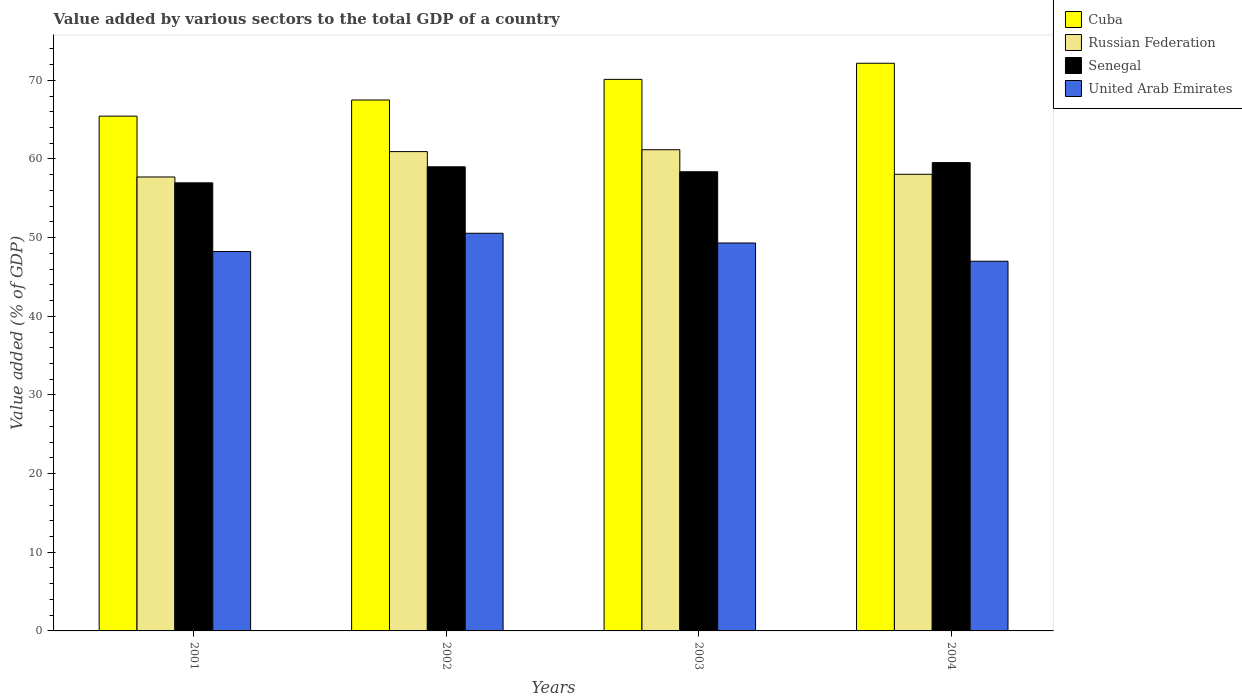How many different coloured bars are there?
Your response must be concise. 4. How many groups of bars are there?
Your answer should be very brief. 4. Are the number of bars per tick equal to the number of legend labels?
Your response must be concise. Yes. How many bars are there on the 3rd tick from the left?
Offer a very short reply. 4. What is the value added by various sectors to the total GDP in United Arab Emirates in 2004?
Your response must be concise. 47. Across all years, what is the maximum value added by various sectors to the total GDP in United Arab Emirates?
Ensure brevity in your answer.  50.56. Across all years, what is the minimum value added by various sectors to the total GDP in Russian Federation?
Ensure brevity in your answer.  57.71. In which year was the value added by various sectors to the total GDP in Cuba maximum?
Ensure brevity in your answer.  2004. What is the total value added by various sectors to the total GDP in Russian Federation in the graph?
Offer a very short reply. 237.87. What is the difference between the value added by various sectors to the total GDP in United Arab Emirates in 2001 and that in 2003?
Ensure brevity in your answer.  -1.08. What is the difference between the value added by various sectors to the total GDP in Cuba in 2001 and the value added by various sectors to the total GDP in Senegal in 2004?
Keep it short and to the point. 5.91. What is the average value added by various sectors to the total GDP in Cuba per year?
Your response must be concise. 68.81. In the year 2001, what is the difference between the value added by various sectors to the total GDP in Senegal and value added by various sectors to the total GDP in United Arab Emirates?
Your answer should be compact. 8.73. In how many years, is the value added by various sectors to the total GDP in United Arab Emirates greater than 22 %?
Keep it short and to the point. 4. What is the ratio of the value added by various sectors to the total GDP in United Arab Emirates in 2001 to that in 2004?
Offer a terse response. 1.03. Is the value added by various sectors to the total GDP in United Arab Emirates in 2003 less than that in 2004?
Give a very brief answer. No. Is the difference between the value added by various sectors to the total GDP in Senegal in 2001 and 2002 greater than the difference between the value added by various sectors to the total GDP in United Arab Emirates in 2001 and 2002?
Offer a terse response. Yes. What is the difference between the highest and the second highest value added by various sectors to the total GDP in Russian Federation?
Make the answer very short. 0.24. What is the difference between the highest and the lowest value added by various sectors to the total GDP in United Arab Emirates?
Ensure brevity in your answer.  3.56. Is the sum of the value added by various sectors to the total GDP in Russian Federation in 2001 and 2002 greater than the maximum value added by various sectors to the total GDP in Senegal across all years?
Keep it short and to the point. Yes. What does the 1st bar from the left in 2002 represents?
Keep it short and to the point. Cuba. What does the 2nd bar from the right in 2004 represents?
Provide a short and direct response. Senegal. Are all the bars in the graph horizontal?
Ensure brevity in your answer.  No. What is the difference between two consecutive major ticks on the Y-axis?
Your response must be concise. 10. Are the values on the major ticks of Y-axis written in scientific E-notation?
Your response must be concise. No. Does the graph contain any zero values?
Offer a very short reply. No. Does the graph contain grids?
Keep it short and to the point. No. How are the legend labels stacked?
Give a very brief answer. Vertical. What is the title of the graph?
Offer a terse response. Value added by various sectors to the total GDP of a country. What is the label or title of the X-axis?
Offer a very short reply. Years. What is the label or title of the Y-axis?
Your response must be concise. Value added (% of GDP). What is the Value added (% of GDP) in Cuba in 2001?
Offer a terse response. 65.44. What is the Value added (% of GDP) in Russian Federation in 2001?
Your response must be concise. 57.71. What is the Value added (% of GDP) in Senegal in 2001?
Your answer should be compact. 56.96. What is the Value added (% of GDP) in United Arab Emirates in 2001?
Offer a terse response. 48.23. What is the Value added (% of GDP) of Cuba in 2002?
Your response must be concise. 67.5. What is the Value added (% of GDP) in Russian Federation in 2002?
Ensure brevity in your answer.  60.94. What is the Value added (% of GDP) in Senegal in 2002?
Keep it short and to the point. 59.01. What is the Value added (% of GDP) in United Arab Emirates in 2002?
Keep it short and to the point. 50.56. What is the Value added (% of GDP) in Cuba in 2003?
Your answer should be very brief. 70.12. What is the Value added (% of GDP) of Russian Federation in 2003?
Your answer should be very brief. 61.17. What is the Value added (% of GDP) of Senegal in 2003?
Keep it short and to the point. 58.37. What is the Value added (% of GDP) of United Arab Emirates in 2003?
Provide a short and direct response. 49.32. What is the Value added (% of GDP) of Cuba in 2004?
Make the answer very short. 72.17. What is the Value added (% of GDP) in Russian Federation in 2004?
Your response must be concise. 58.05. What is the Value added (% of GDP) of Senegal in 2004?
Provide a succinct answer. 59.54. What is the Value added (% of GDP) of United Arab Emirates in 2004?
Offer a very short reply. 47. Across all years, what is the maximum Value added (% of GDP) of Cuba?
Your response must be concise. 72.17. Across all years, what is the maximum Value added (% of GDP) of Russian Federation?
Your answer should be compact. 61.17. Across all years, what is the maximum Value added (% of GDP) of Senegal?
Offer a terse response. 59.54. Across all years, what is the maximum Value added (% of GDP) of United Arab Emirates?
Offer a terse response. 50.56. Across all years, what is the minimum Value added (% of GDP) in Cuba?
Offer a very short reply. 65.44. Across all years, what is the minimum Value added (% of GDP) in Russian Federation?
Give a very brief answer. 57.71. Across all years, what is the minimum Value added (% of GDP) in Senegal?
Offer a very short reply. 56.96. Across all years, what is the minimum Value added (% of GDP) in United Arab Emirates?
Your answer should be compact. 47. What is the total Value added (% of GDP) in Cuba in the graph?
Your answer should be compact. 275.23. What is the total Value added (% of GDP) in Russian Federation in the graph?
Ensure brevity in your answer.  237.87. What is the total Value added (% of GDP) in Senegal in the graph?
Your answer should be compact. 233.88. What is the total Value added (% of GDP) of United Arab Emirates in the graph?
Your response must be concise. 195.1. What is the difference between the Value added (% of GDP) of Cuba in 2001 and that in 2002?
Keep it short and to the point. -2.05. What is the difference between the Value added (% of GDP) in Russian Federation in 2001 and that in 2002?
Your answer should be compact. -3.22. What is the difference between the Value added (% of GDP) of Senegal in 2001 and that in 2002?
Your response must be concise. -2.04. What is the difference between the Value added (% of GDP) in United Arab Emirates in 2001 and that in 2002?
Ensure brevity in your answer.  -2.32. What is the difference between the Value added (% of GDP) in Cuba in 2001 and that in 2003?
Provide a succinct answer. -4.68. What is the difference between the Value added (% of GDP) of Russian Federation in 2001 and that in 2003?
Your answer should be very brief. -3.46. What is the difference between the Value added (% of GDP) of Senegal in 2001 and that in 2003?
Ensure brevity in your answer.  -1.41. What is the difference between the Value added (% of GDP) in United Arab Emirates in 2001 and that in 2003?
Offer a terse response. -1.08. What is the difference between the Value added (% of GDP) of Cuba in 2001 and that in 2004?
Provide a short and direct response. -6.72. What is the difference between the Value added (% of GDP) of Russian Federation in 2001 and that in 2004?
Ensure brevity in your answer.  -0.34. What is the difference between the Value added (% of GDP) in Senegal in 2001 and that in 2004?
Offer a very short reply. -2.57. What is the difference between the Value added (% of GDP) in United Arab Emirates in 2001 and that in 2004?
Offer a terse response. 1.24. What is the difference between the Value added (% of GDP) of Cuba in 2002 and that in 2003?
Make the answer very short. -2.62. What is the difference between the Value added (% of GDP) of Russian Federation in 2002 and that in 2003?
Your answer should be compact. -0.24. What is the difference between the Value added (% of GDP) of Senegal in 2002 and that in 2003?
Offer a very short reply. 0.63. What is the difference between the Value added (% of GDP) of United Arab Emirates in 2002 and that in 2003?
Give a very brief answer. 1.24. What is the difference between the Value added (% of GDP) of Cuba in 2002 and that in 2004?
Make the answer very short. -4.67. What is the difference between the Value added (% of GDP) in Russian Federation in 2002 and that in 2004?
Provide a succinct answer. 2.88. What is the difference between the Value added (% of GDP) in Senegal in 2002 and that in 2004?
Give a very brief answer. -0.53. What is the difference between the Value added (% of GDP) in United Arab Emirates in 2002 and that in 2004?
Your answer should be compact. 3.56. What is the difference between the Value added (% of GDP) of Cuba in 2003 and that in 2004?
Your response must be concise. -2.05. What is the difference between the Value added (% of GDP) in Russian Federation in 2003 and that in 2004?
Make the answer very short. 3.12. What is the difference between the Value added (% of GDP) of Senegal in 2003 and that in 2004?
Make the answer very short. -1.16. What is the difference between the Value added (% of GDP) of United Arab Emirates in 2003 and that in 2004?
Provide a short and direct response. 2.32. What is the difference between the Value added (% of GDP) in Cuba in 2001 and the Value added (% of GDP) in Russian Federation in 2002?
Provide a short and direct response. 4.51. What is the difference between the Value added (% of GDP) in Cuba in 2001 and the Value added (% of GDP) in Senegal in 2002?
Offer a very short reply. 6.44. What is the difference between the Value added (% of GDP) of Cuba in 2001 and the Value added (% of GDP) of United Arab Emirates in 2002?
Make the answer very short. 14.89. What is the difference between the Value added (% of GDP) of Russian Federation in 2001 and the Value added (% of GDP) of Senegal in 2002?
Give a very brief answer. -1.29. What is the difference between the Value added (% of GDP) in Russian Federation in 2001 and the Value added (% of GDP) in United Arab Emirates in 2002?
Provide a succinct answer. 7.16. What is the difference between the Value added (% of GDP) of Senegal in 2001 and the Value added (% of GDP) of United Arab Emirates in 2002?
Your answer should be compact. 6.41. What is the difference between the Value added (% of GDP) of Cuba in 2001 and the Value added (% of GDP) of Russian Federation in 2003?
Your answer should be very brief. 4.27. What is the difference between the Value added (% of GDP) in Cuba in 2001 and the Value added (% of GDP) in Senegal in 2003?
Your response must be concise. 7.07. What is the difference between the Value added (% of GDP) of Cuba in 2001 and the Value added (% of GDP) of United Arab Emirates in 2003?
Offer a terse response. 16.13. What is the difference between the Value added (% of GDP) of Russian Federation in 2001 and the Value added (% of GDP) of Senegal in 2003?
Make the answer very short. -0.66. What is the difference between the Value added (% of GDP) of Russian Federation in 2001 and the Value added (% of GDP) of United Arab Emirates in 2003?
Provide a succinct answer. 8.39. What is the difference between the Value added (% of GDP) in Senegal in 2001 and the Value added (% of GDP) in United Arab Emirates in 2003?
Keep it short and to the point. 7.65. What is the difference between the Value added (% of GDP) of Cuba in 2001 and the Value added (% of GDP) of Russian Federation in 2004?
Ensure brevity in your answer.  7.39. What is the difference between the Value added (% of GDP) of Cuba in 2001 and the Value added (% of GDP) of Senegal in 2004?
Your response must be concise. 5.91. What is the difference between the Value added (% of GDP) of Cuba in 2001 and the Value added (% of GDP) of United Arab Emirates in 2004?
Offer a very short reply. 18.45. What is the difference between the Value added (% of GDP) of Russian Federation in 2001 and the Value added (% of GDP) of Senegal in 2004?
Offer a terse response. -1.82. What is the difference between the Value added (% of GDP) in Russian Federation in 2001 and the Value added (% of GDP) in United Arab Emirates in 2004?
Give a very brief answer. 10.71. What is the difference between the Value added (% of GDP) of Senegal in 2001 and the Value added (% of GDP) of United Arab Emirates in 2004?
Give a very brief answer. 9.97. What is the difference between the Value added (% of GDP) of Cuba in 2002 and the Value added (% of GDP) of Russian Federation in 2003?
Offer a very short reply. 6.32. What is the difference between the Value added (% of GDP) in Cuba in 2002 and the Value added (% of GDP) in Senegal in 2003?
Make the answer very short. 9.12. What is the difference between the Value added (% of GDP) of Cuba in 2002 and the Value added (% of GDP) of United Arab Emirates in 2003?
Offer a terse response. 18.18. What is the difference between the Value added (% of GDP) of Russian Federation in 2002 and the Value added (% of GDP) of Senegal in 2003?
Provide a short and direct response. 2.56. What is the difference between the Value added (% of GDP) in Russian Federation in 2002 and the Value added (% of GDP) in United Arab Emirates in 2003?
Make the answer very short. 11.62. What is the difference between the Value added (% of GDP) in Senegal in 2002 and the Value added (% of GDP) in United Arab Emirates in 2003?
Make the answer very short. 9.69. What is the difference between the Value added (% of GDP) of Cuba in 2002 and the Value added (% of GDP) of Russian Federation in 2004?
Make the answer very short. 9.44. What is the difference between the Value added (% of GDP) of Cuba in 2002 and the Value added (% of GDP) of Senegal in 2004?
Offer a terse response. 7.96. What is the difference between the Value added (% of GDP) in Cuba in 2002 and the Value added (% of GDP) in United Arab Emirates in 2004?
Offer a terse response. 20.5. What is the difference between the Value added (% of GDP) in Russian Federation in 2002 and the Value added (% of GDP) in Senegal in 2004?
Your answer should be very brief. 1.4. What is the difference between the Value added (% of GDP) in Russian Federation in 2002 and the Value added (% of GDP) in United Arab Emirates in 2004?
Provide a short and direct response. 13.94. What is the difference between the Value added (% of GDP) in Senegal in 2002 and the Value added (% of GDP) in United Arab Emirates in 2004?
Keep it short and to the point. 12.01. What is the difference between the Value added (% of GDP) in Cuba in 2003 and the Value added (% of GDP) in Russian Federation in 2004?
Your answer should be very brief. 12.07. What is the difference between the Value added (% of GDP) of Cuba in 2003 and the Value added (% of GDP) of Senegal in 2004?
Your answer should be compact. 10.58. What is the difference between the Value added (% of GDP) in Cuba in 2003 and the Value added (% of GDP) in United Arab Emirates in 2004?
Make the answer very short. 23.12. What is the difference between the Value added (% of GDP) of Russian Federation in 2003 and the Value added (% of GDP) of Senegal in 2004?
Your response must be concise. 1.64. What is the difference between the Value added (% of GDP) in Russian Federation in 2003 and the Value added (% of GDP) in United Arab Emirates in 2004?
Provide a succinct answer. 14.18. What is the difference between the Value added (% of GDP) in Senegal in 2003 and the Value added (% of GDP) in United Arab Emirates in 2004?
Give a very brief answer. 11.38. What is the average Value added (% of GDP) in Cuba per year?
Ensure brevity in your answer.  68.81. What is the average Value added (% of GDP) of Russian Federation per year?
Make the answer very short. 59.47. What is the average Value added (% of GDP) in Senegal per year?
Provide a short and direct response. 58.47. What is the average Value added (% of GDP) in United Arab Emirates per year?
Your answer should be compact. 48.78. In the year 2001, what is the difference between the Value added (% of GDP) of Cuba and Value added (% of GDP) of Russian Federation?
Your answer should be very brief. 7.73. In the year 2001, what is the difference between the Value added (% of GDP) in Cuba and Value added (% of GDP) in Senegal?
Your answer should be compact. 8.48. In the year 2001, what is the difference between the Value added (% of GDP) of Cuba and Value added (% of GDP) of United Arab Emirates?
Ensure brevity in your answer.  17.21. In the year 2001, what is the difference between the Value added (% of GDP) in Russian Federation and Value added (% of GDP) in Senegal?
Provide a succinct answer. 0.75. In the year 2001, what is the difference between the Value added (% of GDP) of Russian Federation and Value added (% of GDP) of United Arab Emirates?
Provide a succinct answer. 9.48. In the year 2001, what is the difference between the Value added (% of GDP) of Senegal and Value added (% of GDP) of United Arab Emirates?
Your answer should be compact. 8.73. In the year 2002, what is the difference between the Value added (% of GDP) in Cuba and Value added (% of GDP) in Russian Federation?
Your answer should be very brief. 6.56. In the year 2002, what is the difference between the Value added (% of GDP) in Cuba and Value added (% of GDP) in Senegal?
Offer a very short reply. 8.49. In the year 2002, what is the difference between the Value added (% of GDP) in Cuba and Value added (% of GDP) in United Arab Emirates?
Your answer should be very brief. 16.94. In the year 2002, what is the difference between the Value added (% of GDP) of Russian Federation and Value added (% of GDP) of Senegal?
Your response must be concise. 1.93. In the year 2002, what is the difference between the Value added (% of GDP) in Russian Federation and Value added (% of GDP) in United Arab Emirates?
Provide a short and direct response. 10.38. In the year 2002, what is the difference between the Value added (% of GDP) in Senegal and Value added (% of GDP) in United Arab Emirates?
Give a very brief answer. 8.45. In the year 2003, what is the difference between the Value added (% of GDP) in Cuba and Value added (% of GDP) in Russian Federation?
Make the answer very short. 8.95. In the year 2003, what is the difference between the Value added (% of GDP) of Cuba and Value added (% of GDP) of Senegal?
Your answer should be very brief. 11.75. In the year 2003, what is the difference between the Value added (% of GDP) of Cuba and Value added (% of GDP) of United Arab Emirates?
Give a very brief answer. 20.8. In the year 2003, what is the difference between the Value added (% of GDP) of Russian Federation and Value added (% of GDP) of Senegal?
Your response must be concise. 2.8. In the year 2003, what is the difference between the Value added (% of GDP) of Russian Federation and Value added (% of GDP) of United Arab Emirates?
Give a very brief answer. 11.86. In the year 2003, what is the difference between the Value added (% of GDP) in Senegal and Value added (% of GDP) in United Arab Emirates?
Provide a succinct answer. 9.05. In the year 2004, what is the difference between the Value added (% of GDP) of Cuba and Value added (% of GDP) of Russian Federation?
Keep it short and to the point. 14.12. In the year 2004, what is the difference between the Value added (% of GDP) of Cuba and Value added (% of GDP) of Senegal?
Offer a terse response. 12.63. In the year 2004, what is the difference between the Value added (% of GDP) of Cuba and Value added (% of GDP) of United Arab Emirates?
Offer a very short reply. 25.17. In the year 2004, what is the difference between the Value added (% of GDP) in Russian Federation and Value added (% of GDP) in Senegal?
Make the answer very short. -1.48. In the year 2004, what is the difference between the Value added (% of GDP) of Russian Federation and Value added (% of GDP) of United Arab Emirates?
Keep it short and to the point. 11.05. In the year 2004, what is the difference between the Value added (% of GDP) in Senegal and Value added (% of GDP) in United Arab Emirates?
Make the answer very short. 12.54. What is the ratio of the Value added (% of GDP) of Cuba in 2001 to that in 2002?
Give a very brief answer. 0.97. What is the ratio of the Value added (% of GDP) in Russian Federation in 2001 to that in 2002?
Your response must be concise. 0.95. What is the ratio of the Value added (% of GDP) in Senegal in 2001 to that in 2002?
Give a very brief answer. 0.97. What is the ratio of the Value added (% of GDP) in United Arab Emirates in 2001 to that in 2002?
Provide a succinct answer. 0.95. What is the ratio of the Value added (% of GDP) of Cuba in 2001 to that in 2003?
Your answer should be very brief. 0.93. What is the ratio of the Value added (% of GDP) in Russian Federation in 2001 to that in 2003?
Offer a terse response. 0.94. What is the ratio of the Value added (% of GDP) of Senegal in 2001 to that in 2003?
Provide a short and direct response. 0.98. What is the ratio of the Value added (% of GDP) of United Arab Emirates in 2001 to that in 2003?
Ensure brevity in your answer.  0.98. What is the ratio of the Value added (% of GDP) in Cuba in 2001 to that in 2004?
Ensure brevity in your answer.  0.91. What is the ratio of the Value added (% of GDP) of Senegal in 2001 to that in 2004?
Provide a succinct answer. 0.96. What is the ratio of the Value added (% of GDP) in United Arab Emirates in 2001 to that in 2004?
Keep it short and to the point. 1.03. What is the ratio of the Value added (% of GDP) of Cuba in 2002 to that in 2003?
Make the answer very short. 0.96. What is the ratio of the Value added (% of GDP) of Senegal in 2002 to that in 2003?
Ensure brevity in your answer.  1.01. What is the ratio of the Value added (% of GDP) in United Arab Emirates in 2002 to that in 2003?
Your answer should be compact. 1.03. What is the ratio of the Value added (% of GDP) of Cuba in 2002 to that in 2004?
Make the answer very short. 0.94. What is the ratio of the Value added (% of GDP) in Russian Federation in 2002 to that in 2004?
Your answer should be very brief. 1.05. What is the ratio of the Value added (% of GDP) in United Arab Emirates in 2002 to that in 2004?
Make the answer very short. 1.08. What is the ratio of the Value added (% of GDP) in Cuba in 2003 to that in 2004?
Offer a very short reply. 0.97. What is the ratio of the Value added (% of GDP) of Russian Federation in 2003 to that in 2004?
Keep it short and to the point. 1.05. What is the ratio of the Value added (% of GDP) of Senegal in 2003 to that in 2004?
Offer a very short reply. 0.98. What is the ratio of the Value added (% of GDP) of United Arab Emirates in 2003 to that in 2004?
Provide a succinct answer. 1.05. What is the difference between the highest and the second highest Value added (% of GDP) of Cuba?
Make the answer very short. 2.05. What is the difference between the highest and the second highest Value added (% of GDP) in Russian Federation?
Your answer should be very brief. 0.24. What is the difference between the highest and the second highest Value added (% of GDP) of Senegal?
Give a very brief answer. 0.53. What is the difference between the highest and the second highest Value added (% of GDP) of United Arab Emirates?
Your answer should be very brief. 1.24. What is the difference between the highest and the lowest Value added (% of GDP) in Cuba?
Offer a terse response. 6.72. What is the difference between the highest and the lowest Value added (% of GDP) in Russian Federation?
Provide a succinct answer. 3.46. What is the difference between the highest and the lowest Value added (% of GDP) of Senegal?
Your answer should be very brief. 2.57. What is the difference between the highest and the lowest Value added (% of GDP) of United Arab Emirates?
Give a very brief answer. 3.56. 